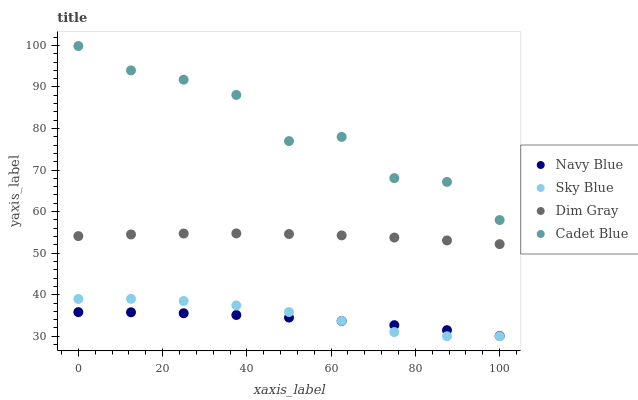Does Navy Blue have the minimum area under the curve?
Answer yes or no. Yes. Does Cadet Blue have the maximum area under the curve?
Answer yes or no. Yes. Does Dim Gray have the minimum area under the curve?
Answer yes or no. No. Does Dim Gray have the maximum area under the curve?
Answer yes or no. No. Is Dim Gray the smoothest?
Answer yes or no. Yes. Is Cadet Blue the roughest?
Answer yes or no. Yes. Is Navy Blue the smoothest?
Answer yes or no. No. Is Navy Blue the roughest?
Answer yes or no. No. Does Sky Blue have the lowest value?
Answer yes or no. Yes. Does Navy Blue have the lowest value?
Answer yes or no. No. Does Cadet Blue have the highest value?
Answer yes or no. Yes. Does Dim Gray have the highest value?
Answer yes or no. No. Is Navy Blue less than Cadet Blue?
Answer yes or no. Yes. Is Cadet Blue greater than Navy Blue?
Answer yes or no. Yes. Does Sky Blue intersect Navy Blue?
Answer yes or no. Yes. Is Sky Blue less than Navy Blue?
Answer yes or no. No. Is Sky Blue greater than Navy Blue?
Answer yes or no. No. Does Navy Blue intersect Cadet Blue?
Answer yes or no. No. 